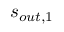Convert formula to latex. <formula><loc_0><loc_0><loc_500><loc_500>s _ { o u t , 1 }</formula> 